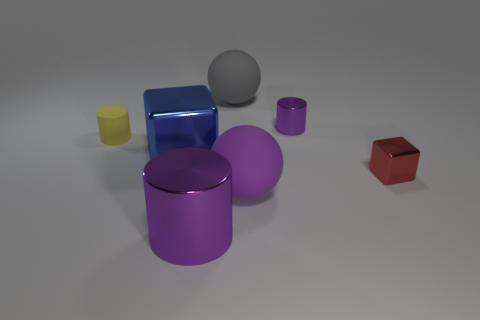Do the small cylinder that is right of the yellow matte cylinder and the purple ball have the same material?
Your answer should be compact. No. What number of things are either big cyan metal objects or blocks to the right of the big purple matte sphere?
Offer a very short reply. 1. The tiny cylinder that is made of the same material as the tiny red block is what color?
Provide a short and direct response. Purple. What number of large gray balls have the same material as the small purple thing?
Offer a very short reply. 0. How many large metal cylinders are there?
Ensure brevity in your answer.  1. Is the color of the small cylinder behind the yellow rubber cylinder the same as the large sphere that is in front of the small purple metal thing?
Your answer should be very brief. Yes. There is a purple ball; how many shiny objects are on the left side of it?
Give a very brief answer. 2. There is a big cylinder that is the same color as the tiny metal cylinder; what material is it?
Ensure brevity in your answer.  Metal. Are there any purple rubber things that have the same shape as the gray matte thing?
Offer a terse response. Yes. Does the big blue block in front of the big gray sphere have the same material as the tiny cylinder behind the yellow object?
Ensure brevity in your answer.  Yes. 